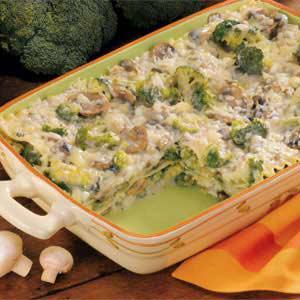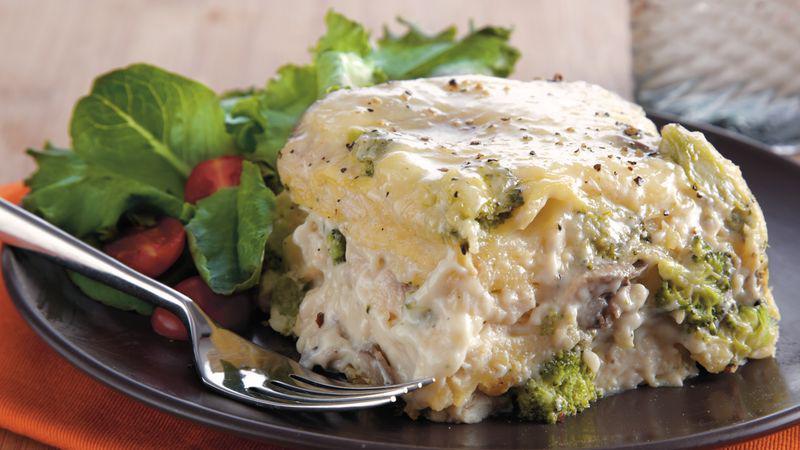The first image is the image on the left, the second image is the image on the right. Analyze the images presented: Is the assertion "There is a green leafy garnish on one of the plates of food." valid? Answer yes or no. Yes. 